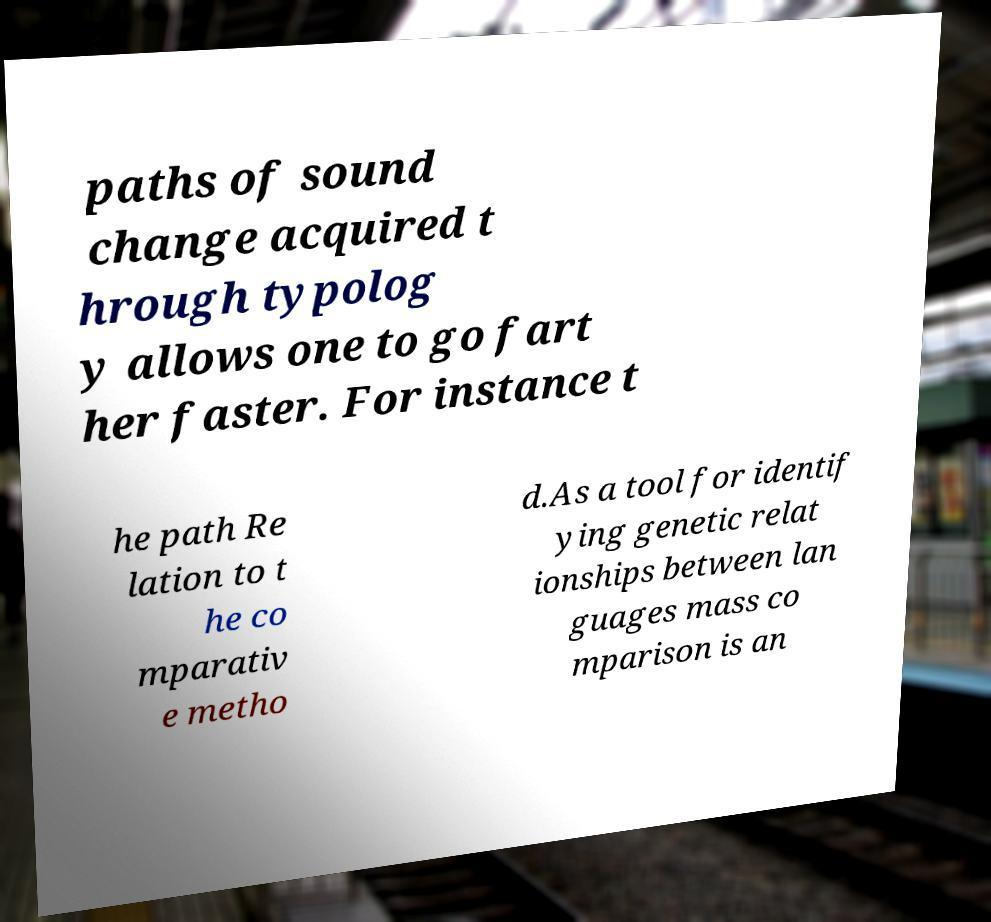What messages or text are displayed in this image? I need them in a readable, typed format. paths of sound change acquired t hrough typolog y allows one to go fart her faster. For instance t he path Re lation to t he co mparativ e metho d.As a tool for identif ying genetic relat ionships between lan guages mass co mparison is an 